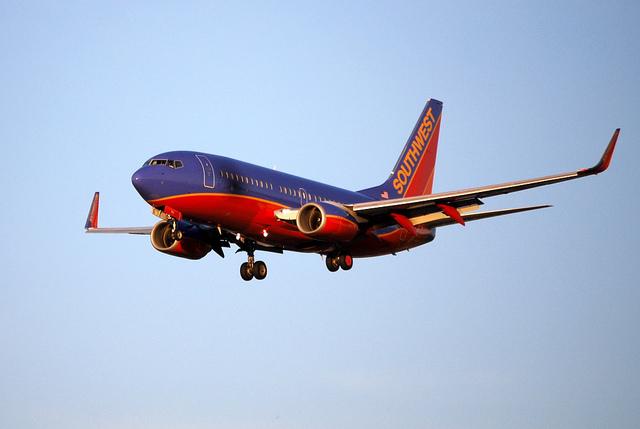What kind of weather is the plane flying through?
Be succinct. Clear. Is the landing gear down?
Keep it brief. Yes. Is this a Southwest airplane?
Write a very short answer. Yes. 